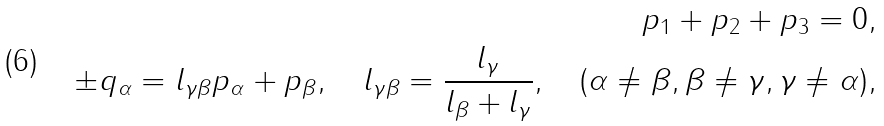<formula> <loc_0><loc_0><loc_500><loc_500>p _ { 1 } + p _ { 2 } + p _ { 3 } = 0 , \\ \pm q _ { \alpha } = l _ { \gamma \beta } p _ { \alpha } + p _ { \beta } , \quad l _ { \gamma \beta } = \frac { l _ { \gamma } } { l _ { \beta } + l _ { \gamma } } , \quad ( \alpha \neq \beta , \beta \neq \gamma , \gamma \neq \alpha ) ,</formula> 